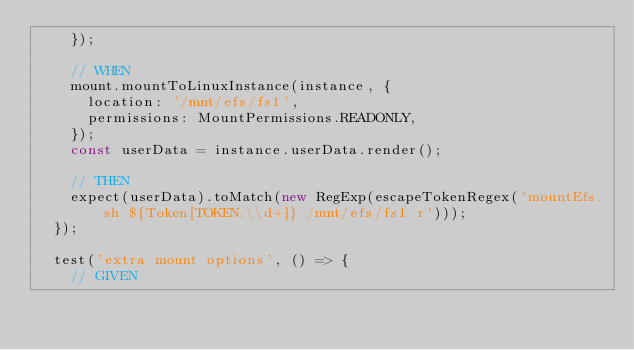Convert code to text. <code><loc_0><loc_0><loc_500><loc_500><_TypeScript_>    });

    // WHEN
    mount.mountToLinuxInstance(instance, {
      location: '/mnt/efs/fs1',
      permissions: MountPermissions.READONLY,
    });
    const userData = instance.userData.render();

    // THEN
    expect(userData).toMatch(new RegExp(escapeTokenRegex('mountEfs.sh ${Token[TOKEN.\\d+]} /mnt/efs/fs1 r')));
  });

  test('extra mount options', () => {
    // GIVEN</code> 